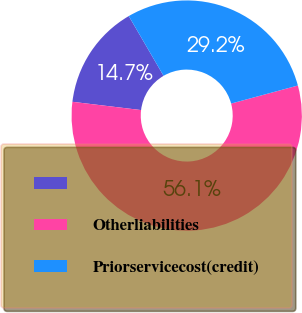Convert chart to OTSL. <chart><loc_0><loc_0><loc_500><loc_500><pie_chart><ecel><fcel>Otherliabilities<fcel>Priorservicecost(credit)<nl><fcel>14.7%<fcel>56.11%<fcel>29.19%<nl></chart> 